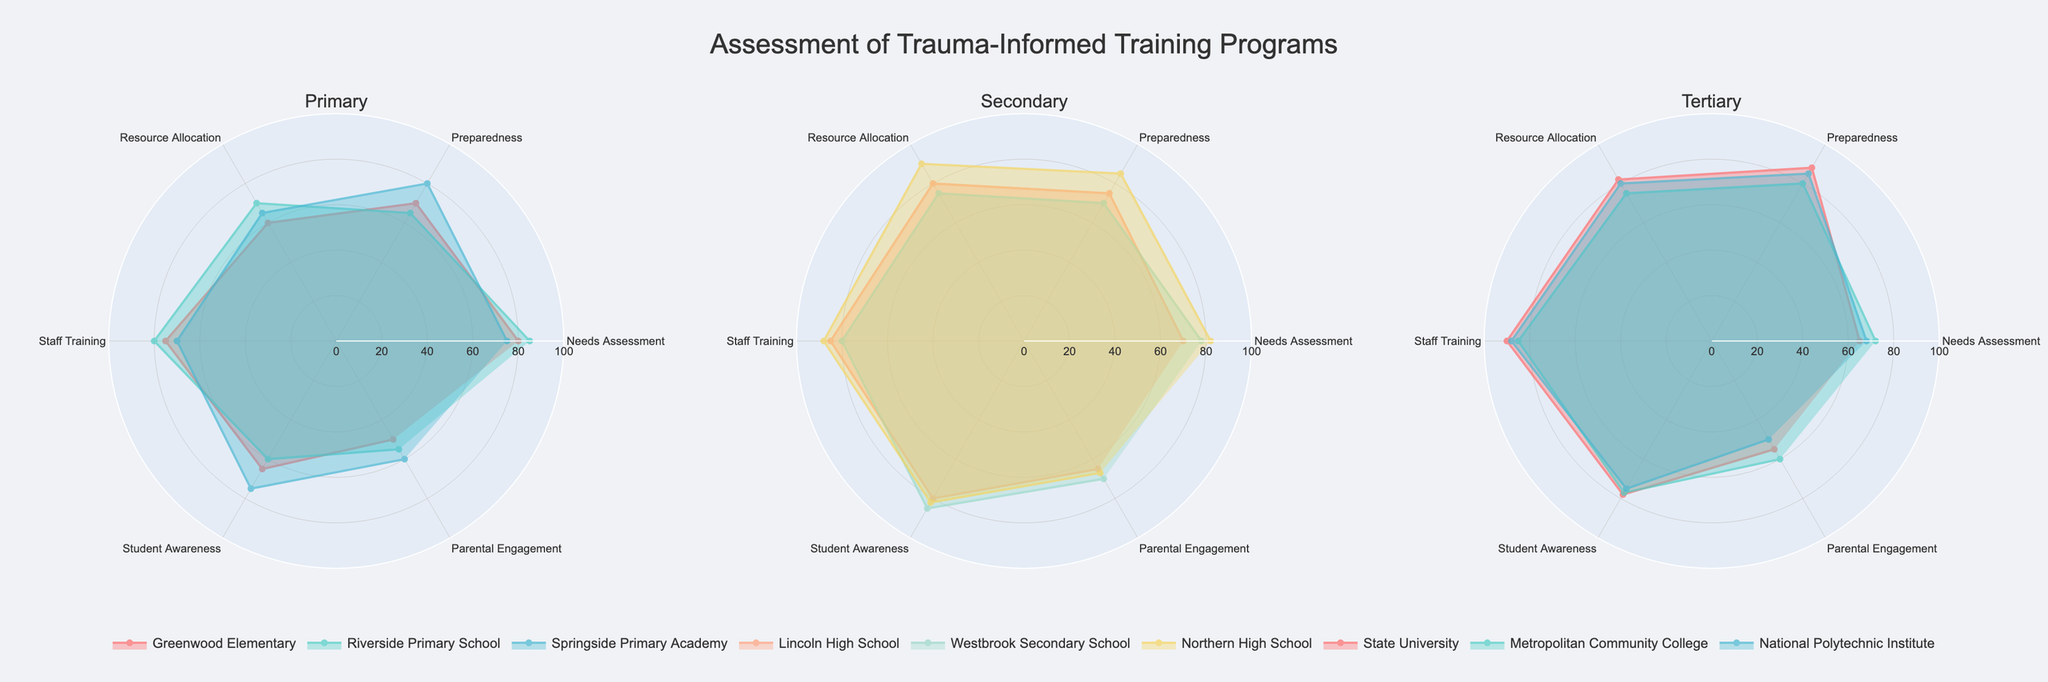Is the "Needs Assessment" score higher for Greenwood Elementary or Riverside Primary School? Compare the "Needs Assessment" scores on the radar chart for Greenwood Elementary and Riverside Primary School within the Primary institutions. Greenwood Elementary has a score of 80, while Riverside Primary School has a score of 85.
Answer: Riverside Primary School Which institution has the highest "Student Awareness" score at the Primary level? Examine the "Student Awareness" scores for Primary institutions. For Greenwood Elementary, it is 65; for Riverside Primary School, it is 60; and for Springside Primary Academy, it is 75.
Answer: Springside Primary Academy What is the average "Preparedness" score for Tertiary institutions? Calculate the average "Preparedness" score for Tertiary institutions: State University (88), Metropolitan Community College (80), and National Polytechnic Institute (85). The calculation is (88 + 80 + 85) / 3 = 253 / 3 = 84.33.
Answer: 84.33 How does Lincoln High School’s "Staff Training" score compare to Westbrook Secondary School’s score? Compare the "Staff Training" scores between Lincoln High School and Westbrook Secondary School. Lincoln High School has a score of 85, while Westbrook Secondary School has a score of 80.
Answer: Lincoln High School's score is higher What is the lowest score observed for "Parental Engagement" across all the institutions? Identify the "Parental Engagement" scores for all institutions: Greenwood Elementary (50), Riverside Primary School (55), Springside Primary Academy (60), Lincoln High School (65), Westbrook Secondary School (70), Northern High School (67), State University (55), Metropolitan Community College (60), National Polytechnic Institute (50). The lowest is 50.
Answer: 50 Rank the Tertiary institutions by their "Resource Allocation" score. Compare "Resource Allocation" scores at the Tertiary level: State University (82), Metropolitan Community College (75), and National Polytechnic Institute (80). The ranked order is State University, National Polytechnic Institute, Metropolitan Community College.
Answer: State University, National Polytechnic Institute, Metropolitan Community College Which Secondary institution has the most balanced scores across all categories? Evaluate the radar chart for each Secondary institution (Lincoln High School, Westbrook Secondary School, Northern High School) by comparing the spread of their scores across categories. Northern High School has scores closely matched (82-90 range), indicating balance.
Answer: Northern High School Compare the median "Needs Assessment" score between Primary and Secondary institutions. Determine the "Needs Assessment" scores and calculate the median for both levels. Primary: Greenwood Elementary (80), Riverside Primary School (85), Springside Primary Academy (75); Median = 80. Secondary: Lincoln High School (70), Westbrook Secondary School (78), Northern High School (82); Median = 78.
Answer: Primary: 80, Secondary: 78 Which institution has the highest "Preparedness" score? Identify the "Preparedness" scores for all institutions and find the highest. Northern High School has a score of 85, State University has a score of 88, and National Polytechnic Institute has a score of 85. The highest is State University with 88.
Answer: State University 